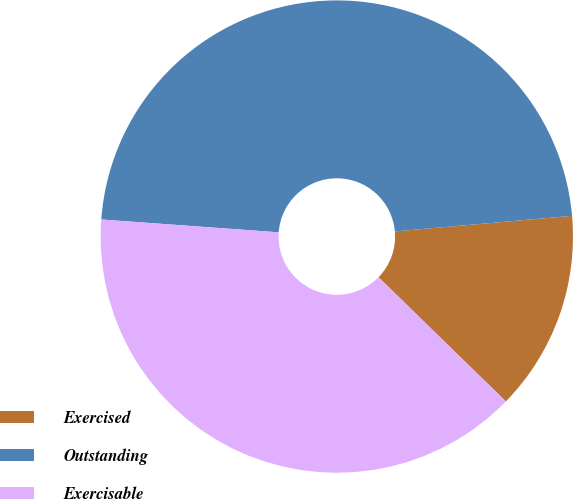Convert chart to OTSL. <chart><loc_0><loc_0><loc_500><loc_500><pie_chart><fcel>Exercised<fcel>Outstanding<fcel>Exercisable<nl><fcel>13.7%<fcel>47.45%<fcel>38.85%<nl></chart> 